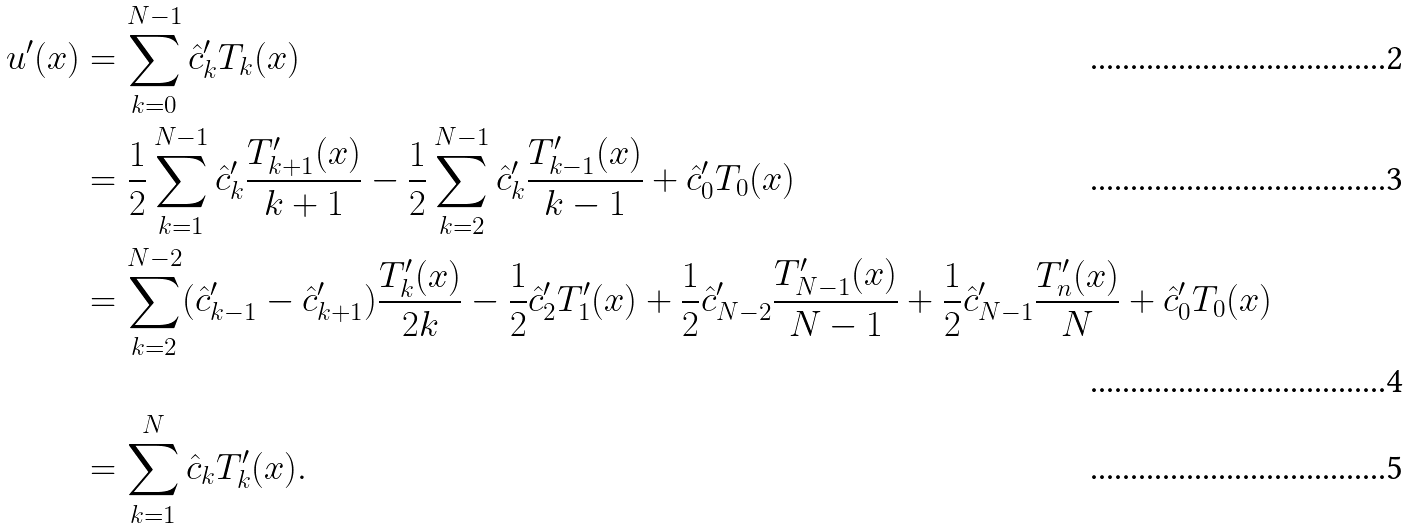<formula> <loc_0><loc_0><loc_500><loc_500>u ^ { \prime } ( x ) & = \sum _ { k = 0 } ^ { N - 1 } \hat { c } ^ { \prime } _ { k } T _ { k } ( x ) \\ & = \frac { 1 } { 2 } \sum _ { k = 1 } ^ { N - 1 } \hat { c } ^ { \prime } _ { k } \frac { T ^ { \prime } _ { k + 1 } ( x ) } { k + 1 } - \frac { 1 } { 2 } \sum _ { k = 2 } ^ { N - 1 } \hat { c } ^ { \prime } _ { k } \frac { T ^ { \prime } _ { k - 1 } ( x ) } { k - 1 } + \hat { c } ^ { \prime } _ { 0 } T _ { 0 } ( x ) \\ & = \sum _ { k = 2 } ^ { N - 2 } ( \hat { c } ^ { \prime } _ { k - 1 } - \hat { c } ^ { \prime } _ { k + 1 } ) \frac { T ^ { \prime } _ { k } ( x ) } { 2 k } - \frac { 1 } { 2 } \hat { c } ^ { \prime } _ { 2 } T ^ { \prime } _ { 1 } ( x ) + \frac { 1 } { 2 } \hat { c } ^ { \prime } _ { N - 2 } \frac { T ^ { \prime } _ { N - 1 } ( x ) } { N - 1 } + \frac { 1 } { 2 } \hat { c } ^ { \prime } _ { N - 1 } \frac { T ^ { \prime } _ { n } ( x ) } { N } + \hat { c } ^ { \prime } _ { 0 } T _ { 0 } ( x ) \\ & = \sum _ { k = 1 } ^ { N } \hat { c } _ { k } T ^ { \prime } _ { k } ( x ) .</formula> 